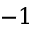Convert formula to latex. <formula><loc_0><loc_0><loc_500><loc_500>- 1</formula> 